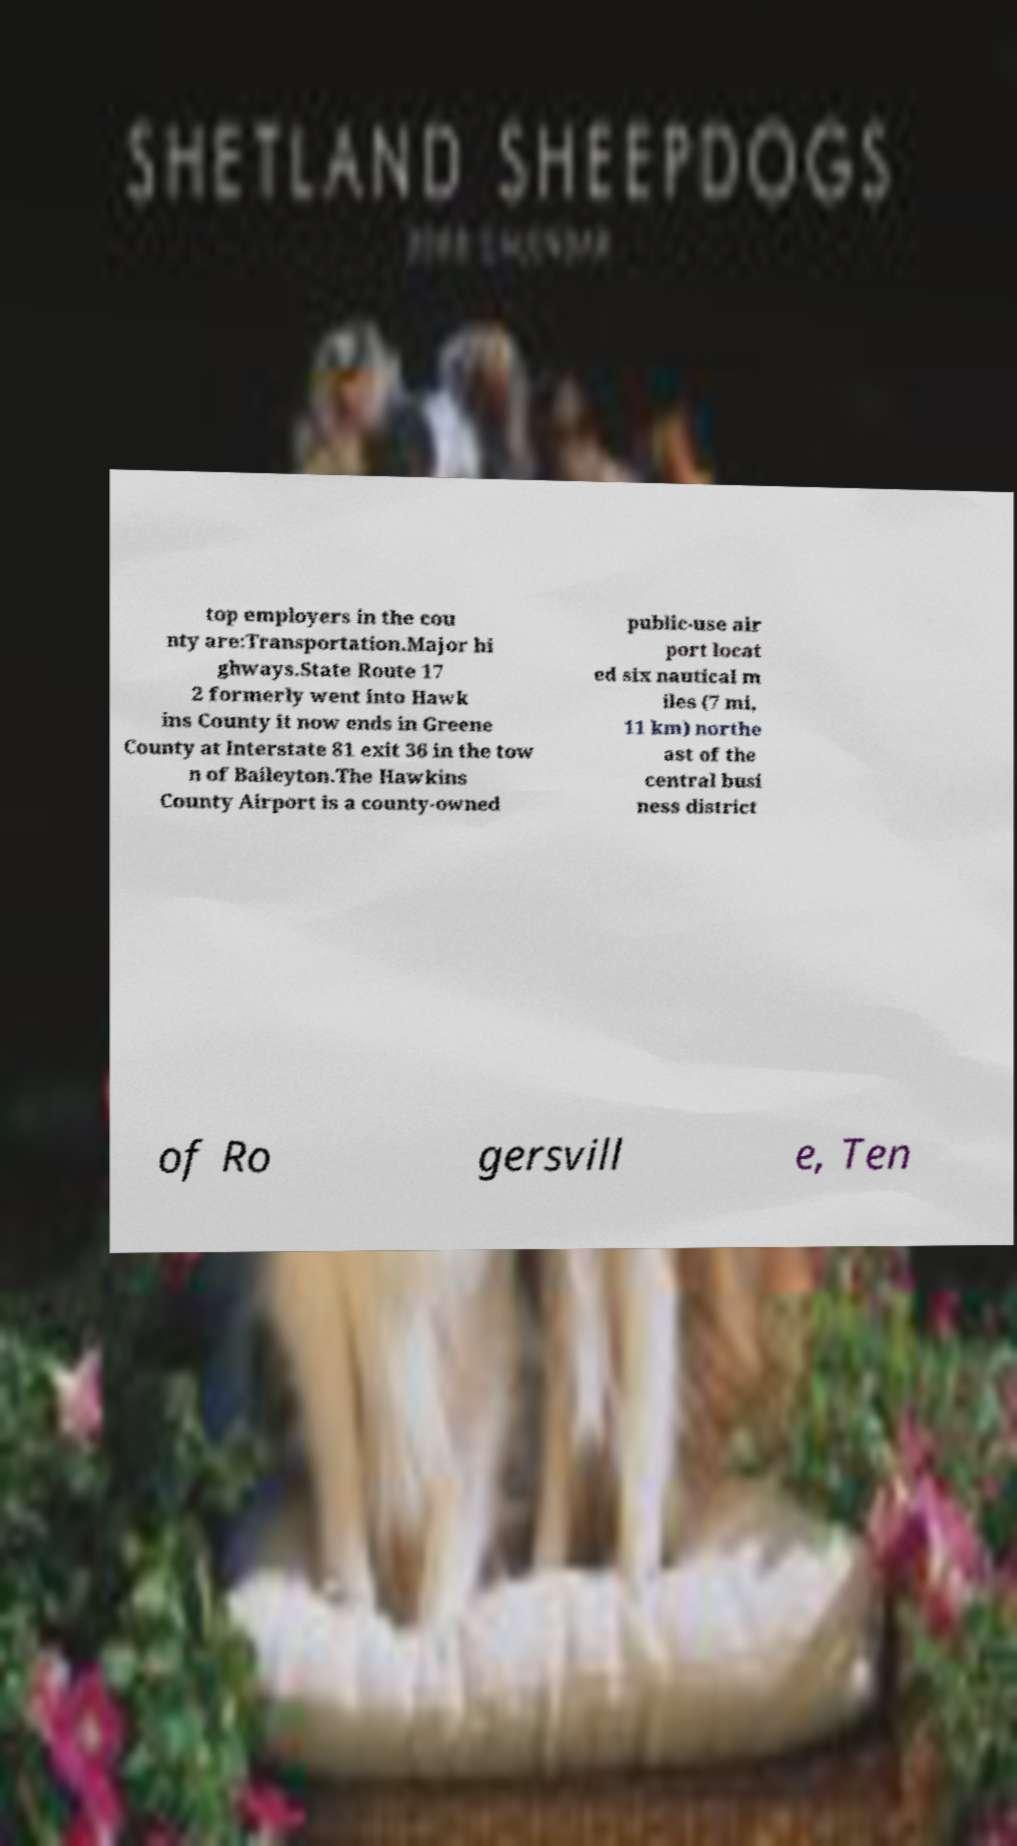Can you accurately transcribe the text from the provided image for me? top employers in the cou nty are:Transportation.Major hi ghways.State Route 17 2 formerly went into Hawk ins County it now ends in Greene County at Interstate 81 exit 36 in the tow n of Baileyton.The Hawkins County Airport is a county-owned public-use air port locat ed six nautical m iles (7 mi, 11 km) northe ast of the central busi ness district of Ro gersvill e, Ten 